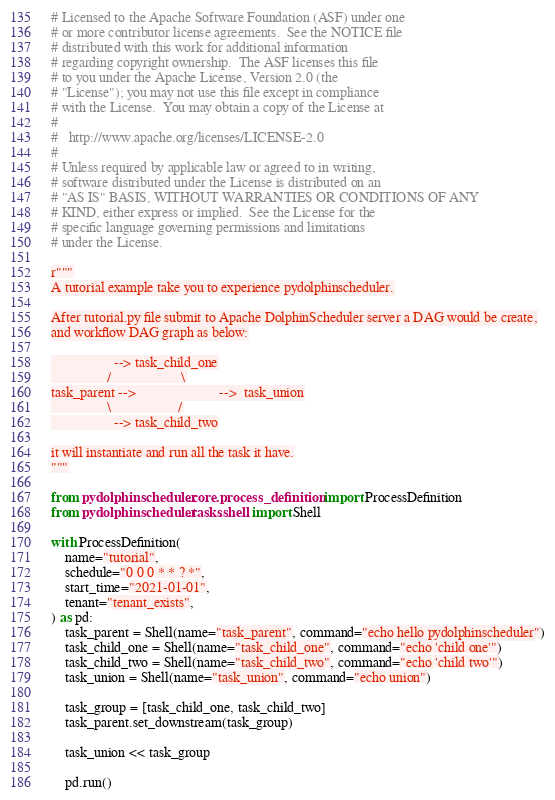<code> <loc_0><loc_0><loc_500><loc_500><_Python_># Licensed to the Apache Software Foundation (ASF) under one
# or more contributor license agreements.  See the NOTICE file
# distributed with this work for additional information
# regarding copyright ownership.  The ASF licenses this file
# to you under the Apache License, Version 2.0 (the
# "License"); you may not use this file except in compliance
# with the License.  You may obtain a copy of the License at
#
#   http://www.apache.org/licenses/LICENSE-2.0
#
# Unless required by applicable law or agreed to in writing,
# software distributed under the License is distributed on an
# "AS IS" BASIS, WITHOUT WARRANTIES OR CONDITIONS OF ANY
# KIND, either express or implied.  See the License for the
# specific language governing permissions and limitations
# under the License.

r"""
A tutorial example take you to experience pydolphinscheduler.

After tutorial.py file submit to Apache DolphinScheduler server a DAG would be create,
and workflow DAG graph as below:

                  --> task_child_one
                /                    \
task_parent -->                        -->  task_union
                \                   /
                  --> task_child_two

it will instantiate and run all the task it have.
"""

from pydolphinscheduler.core.process_definition import ProcessDefinition
from pydolphinscheduler.tasks.shell import Shell

with ProcessDefinition(
    name="tutorial",
    schedule="0 0 0 * * ? *",
    start_time="2021-01-01",
    tenant="tenant_exists",
) as pd:
    task_parent = Shell(name="task_parent", command="echo hello pydolphinscheduler")
    task_child_one = Shell(name="task_child_one", command="echo 'child one'")
    task_child_two = Shell(name="task_child_two", command="echo 'child two'")
    task_union = Shell(name="task_union", command="echo union")

    task_group = [task_child_one, task_child_two]
    task_parent.set_downstream(task_group)

    task_union << task_group

    pd.run()
</code> 